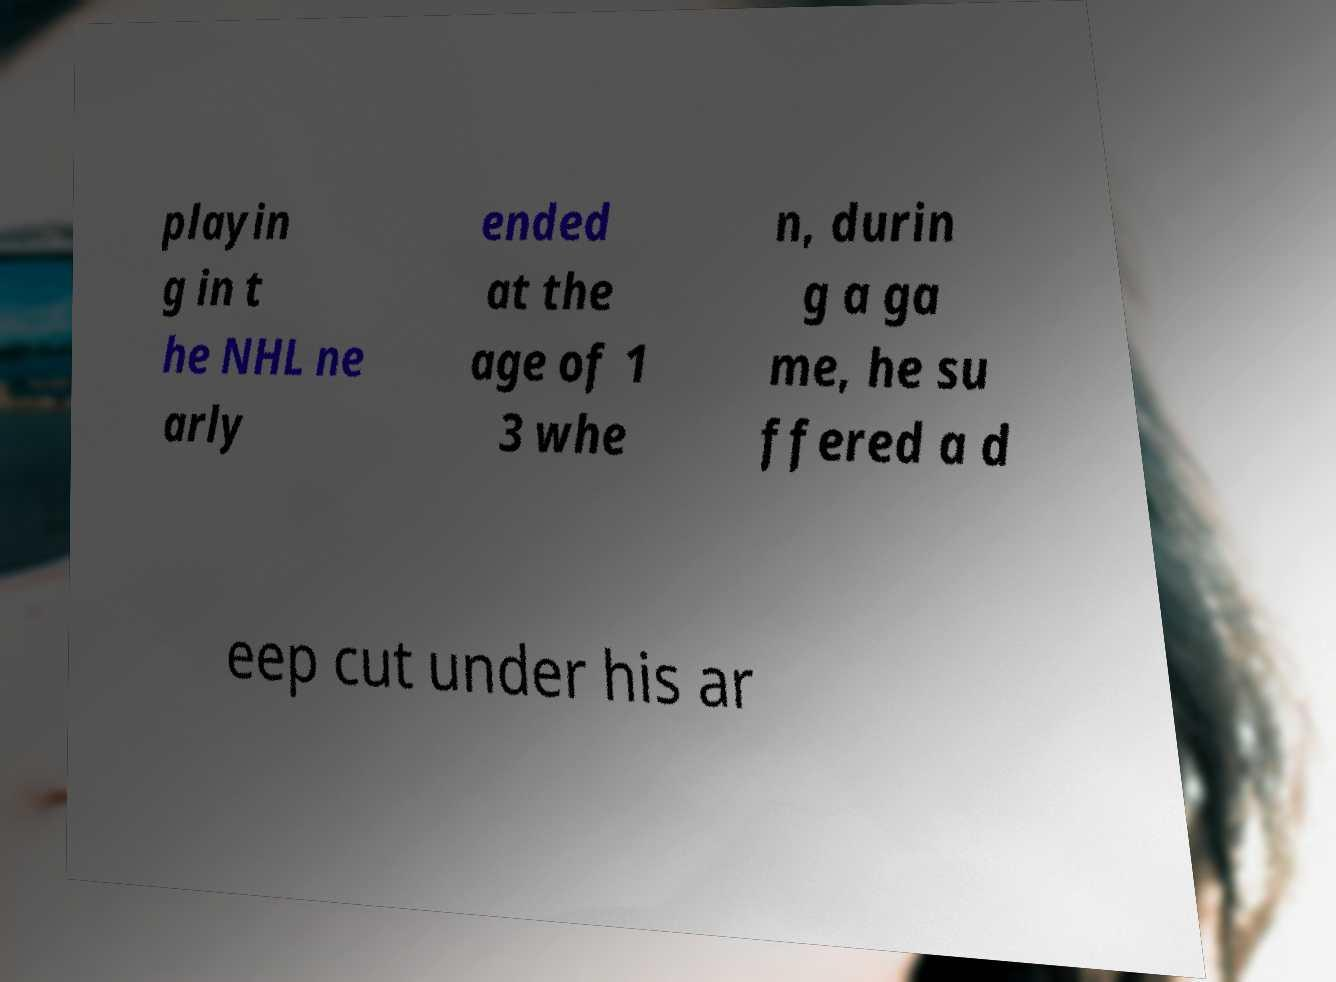There's text embedded in this image that I need extracted. Can you transcribe it verbatim? playin g in t he NHL ne arly ended at the age of 1 3 whe n, durin g a ga me, he su ffered a d eep cut under his ar 